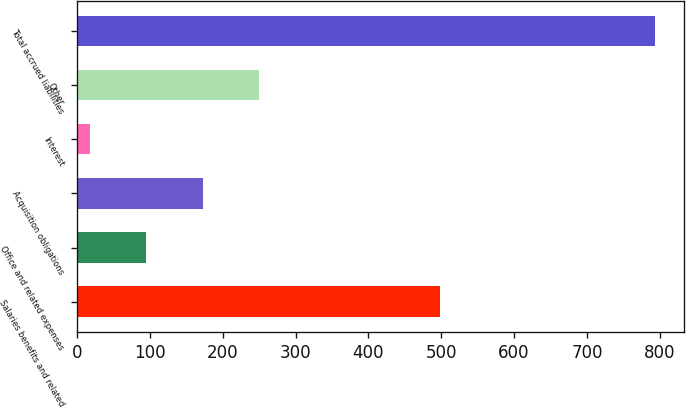Convert chart. <chart><loc_0><loc_0><loc_500><loc_500><bar_chart><fcel>Salaries benefits and related<fcel>Office and related expenses<fcel>Acquisition obligations<fcel>Interest<fcel>Other<fcel>Total accrued liabilities<nl><fcel>499<fcel>94.97<fcel>172.64<fcel>17.3<fcel>250.31<fcel>794<nl></chart> 